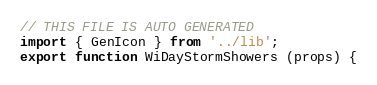Convert code to text. <code><loc_0><loc_0><loc_500><loc_500><_JavaScript_>// THIS FILE IS AUTO GENERATED
import { GenIcon } from '../lib';
export function WiDayStormShowers (props) {</code> 